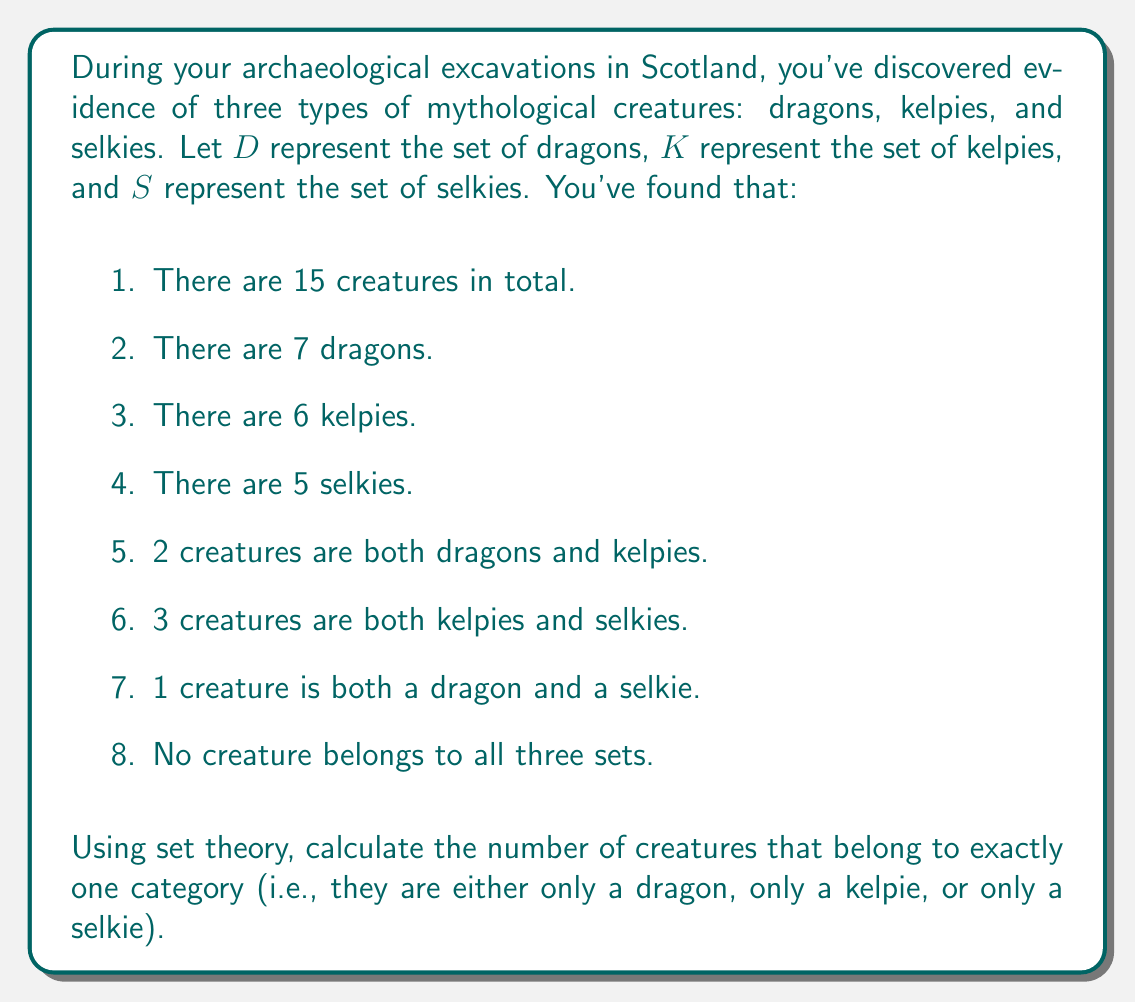Help me with this question. To solve this problem, we'll use the principle of inclusion-exclusion from set theory. Let's break it down step by step:

1. First, let's define the universal set $U$ as all the creatures: $|U| = 15$

2. We're given the following:
   $|D| = 7$, $|K| = 6$, $|S| = 5$
   $|D \cap K| = 2$, $|K \cap S| = 3$, $|D \cap S| = 1$
   $|D \cap K \cap S| = 0$

3. The formula for the number of elements in the union of three sets is:

   $$|D \cup K \cup S| = |D| + |K| + |S| - |D \cap K| - |K \cap S| - |D \cap S| + |D \cap K \cap S|$$

4. Substituting the given values:

   $$|D \cup K \cup S| = 7 + 6 + 5 - 2 - 3 - 1 + 0 = 12$$

5. This means that 12 creatures belong to at least one category.

6. To find the number of creatures that belong to exactly one category, we need to subtract this from the total number of creatures:

   $$15 - 12 = 3$$

Therefore, 3 creatures belong to exactly one category.

We can verify this by calculating the number of creatures in each exclusive category:

- Only dragons: $|D| - |D \cap K| - |D \cap S| + |D \cap K \cap S| = 7 - 2 - 1 + 0 = 4$
- Only kelpies: $|K| - |D \cap K| - |K \cap S| + |D \cap K \cap S| = 6 - 2 - 3 + 0 = 1$
- Only selkies: $|S| - |D \cap S| - |K \cap S| + |D \cap K \cap S| = 5 - 1 - 3 + 0 = 1$

Adding these up: $4 + 1 + 1 = 6$

The sum of creatures belonging to exactly one category (6) and those belonging to more than one category (6) equals the total number of creatures (12), confirming our calculation.
Answer: 3 creatures belong to exactly one category. 